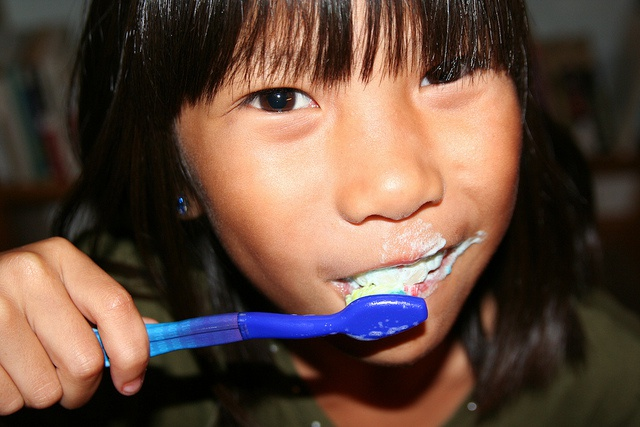Describe the objects in this image and their specific colors. I can see people in black and tan tones and toothbrush in black, blue, and darkblue tones in this image. 